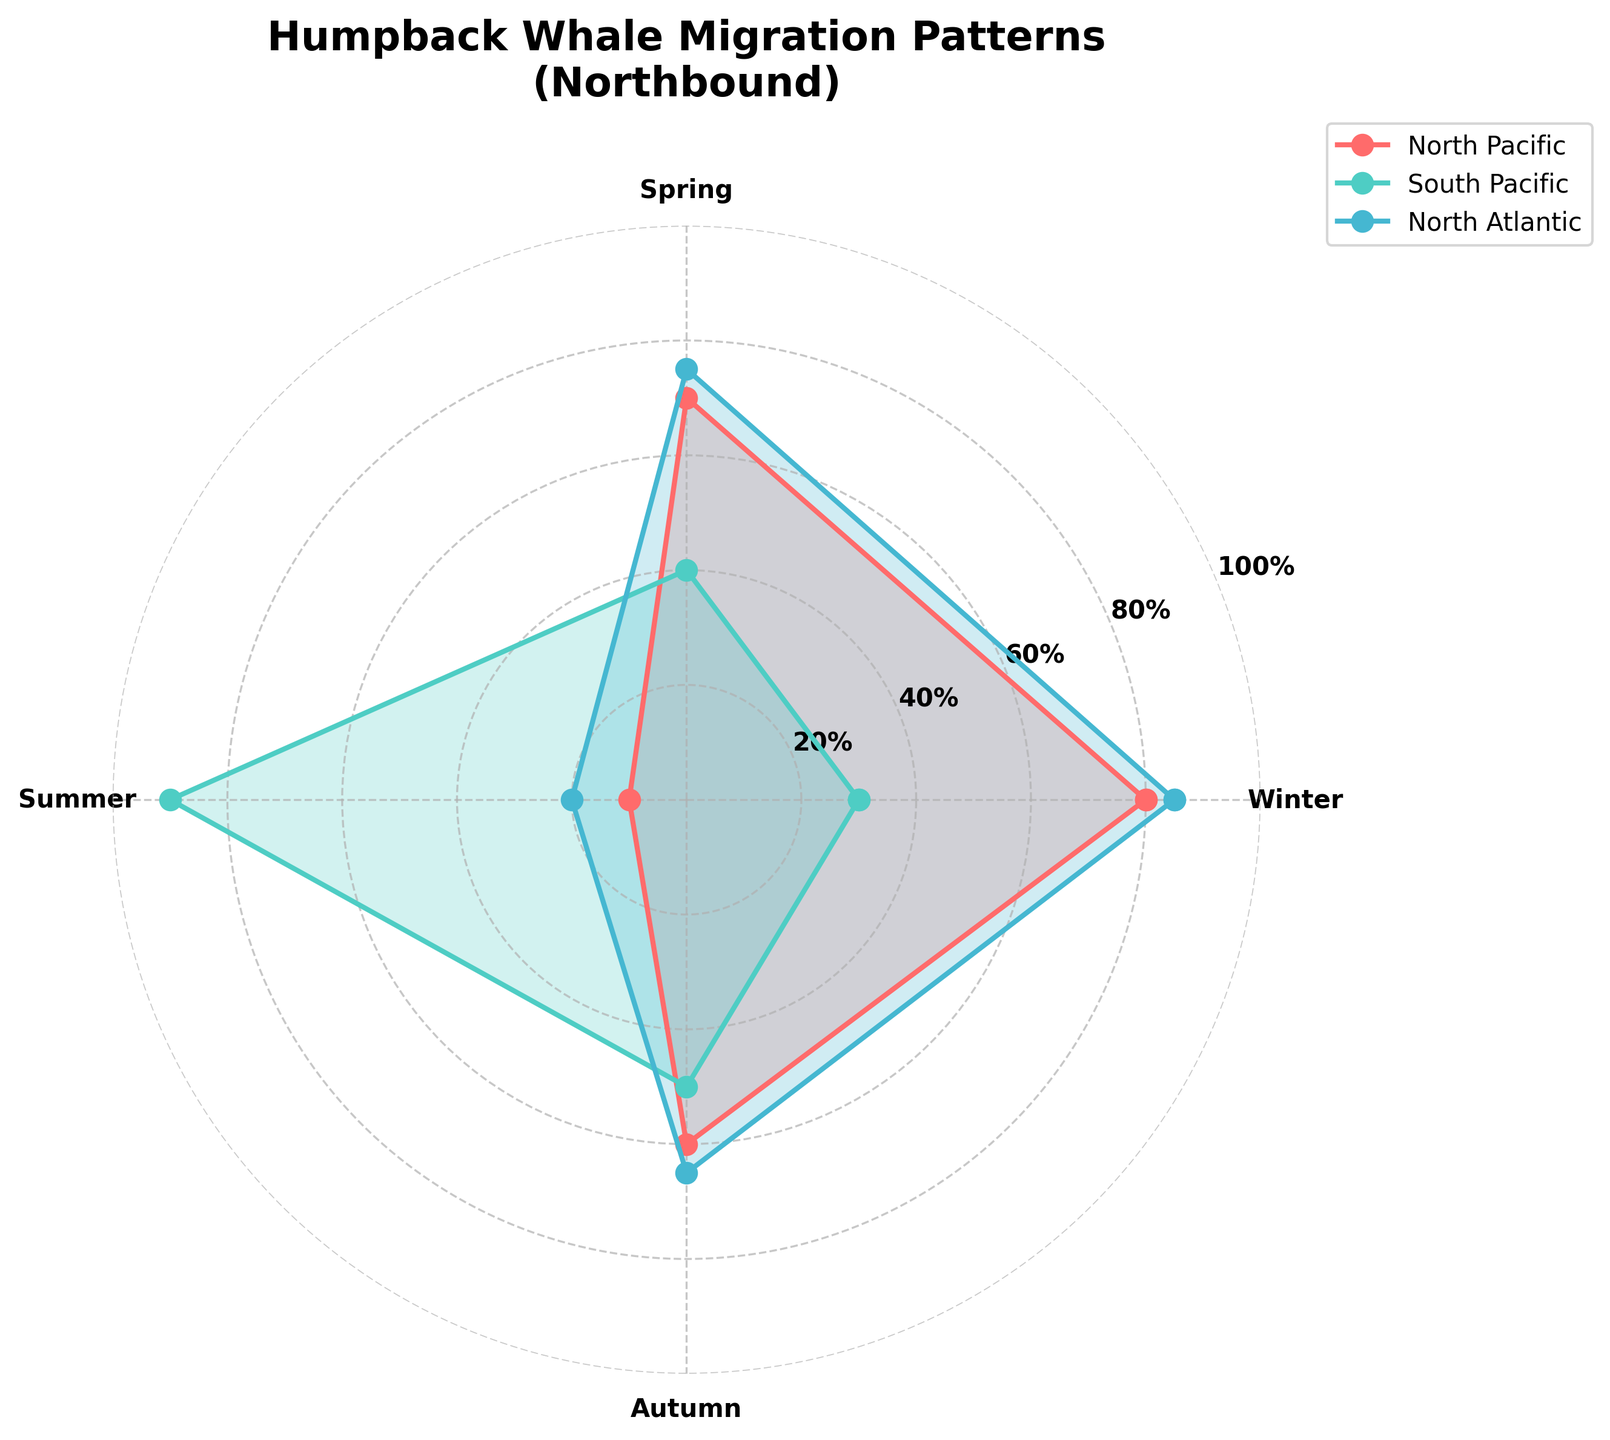What is the title of the chart? The title of the chart is displayed at the top of the figure.
Answer: Humpback Whale Migration Patterns (Northbound) Which season shows the highest Northbound migration percentage for the North Pacific region? Look at the line corresponding to the North Pacific region and find the highest value around the seasons for Northbound migration.
Answer: Winter What is the Northbound migration percentage for the South Pacific region during Spring? Identify the line for the South Pacific region and find the value corresponding to Spring for Northbound migrations.
Answer: 40% Compare the Northbound migration between Winter and Summer for the North Atlantic region. In which season is it higher? Check the values for Winter and Summer on the North Atlantic line and compare them.
Answer: Winter What is the sum of the Northbound migration percentages during Spring and Autumn for the South Pacific region? Add the Northbound migration percentages for Spring and Autumn for the South Pacific region.
Answer: 40 + 50 = 90 Which ocean region shows the lowest Northbound migration percentage during Summer? Identify the lowest value of the Northbound migration percentages for Summer across all displayed ocean regions.
Answer: North Pacific Rank the ocean regions based on their Northbound migration percentage during Autumn from highest to lowest. Check the Northbound migration percentages for Autumn and rank them in descending order.
Answer: North Atlantic, North Pacific, South Atlantic, South Pacific By how many percentage points does the Northbound migration during Winter in the North Atlantic exceed the South Pacific's Northbound migration during Spring? Subtract the South Pacific's Spring value from the North Atlantic's Winter value to find the difference.
Answer: 85 - 40 = 45 What is the average Northbound migration percentage across all seasons for the North Pacific region? Add all the Northbound migration percentages for the North Pacific region and divide by the number of seasons.
Answer: (80 + 70 + 10 + 60) / 4 = 55 Which two seasons show the most similar Northbound migration percentages for the South Atlantic region? Compare the Northbound migration percentages of South Atlantic across all seasons to find the two closest values.
Answer: Spring and Autumn 